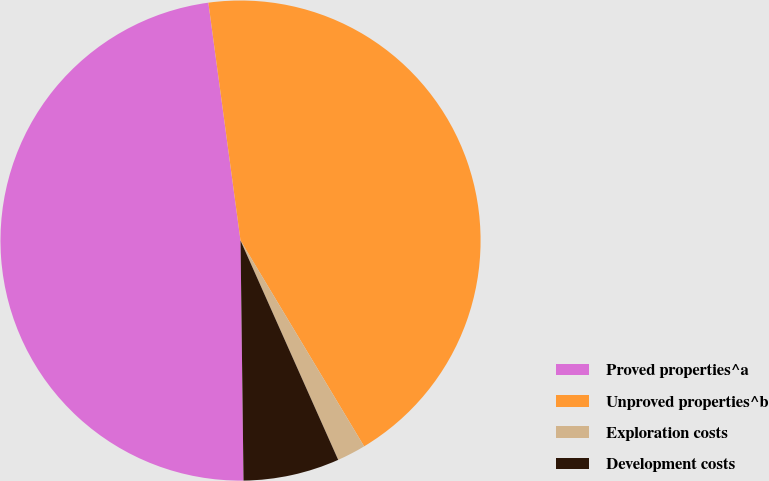<chart> <loc_0><loc_0><loc_500><loc_500><pie_chart><fcel>Proved properties^a<fcel>Unproved properties^b<fcel>Exploration costs<fcel>Development costs<nl><fcel>48.06%<fcel>43.53%<fcel>1.94%<fcel>6.47%<nl></chart> 